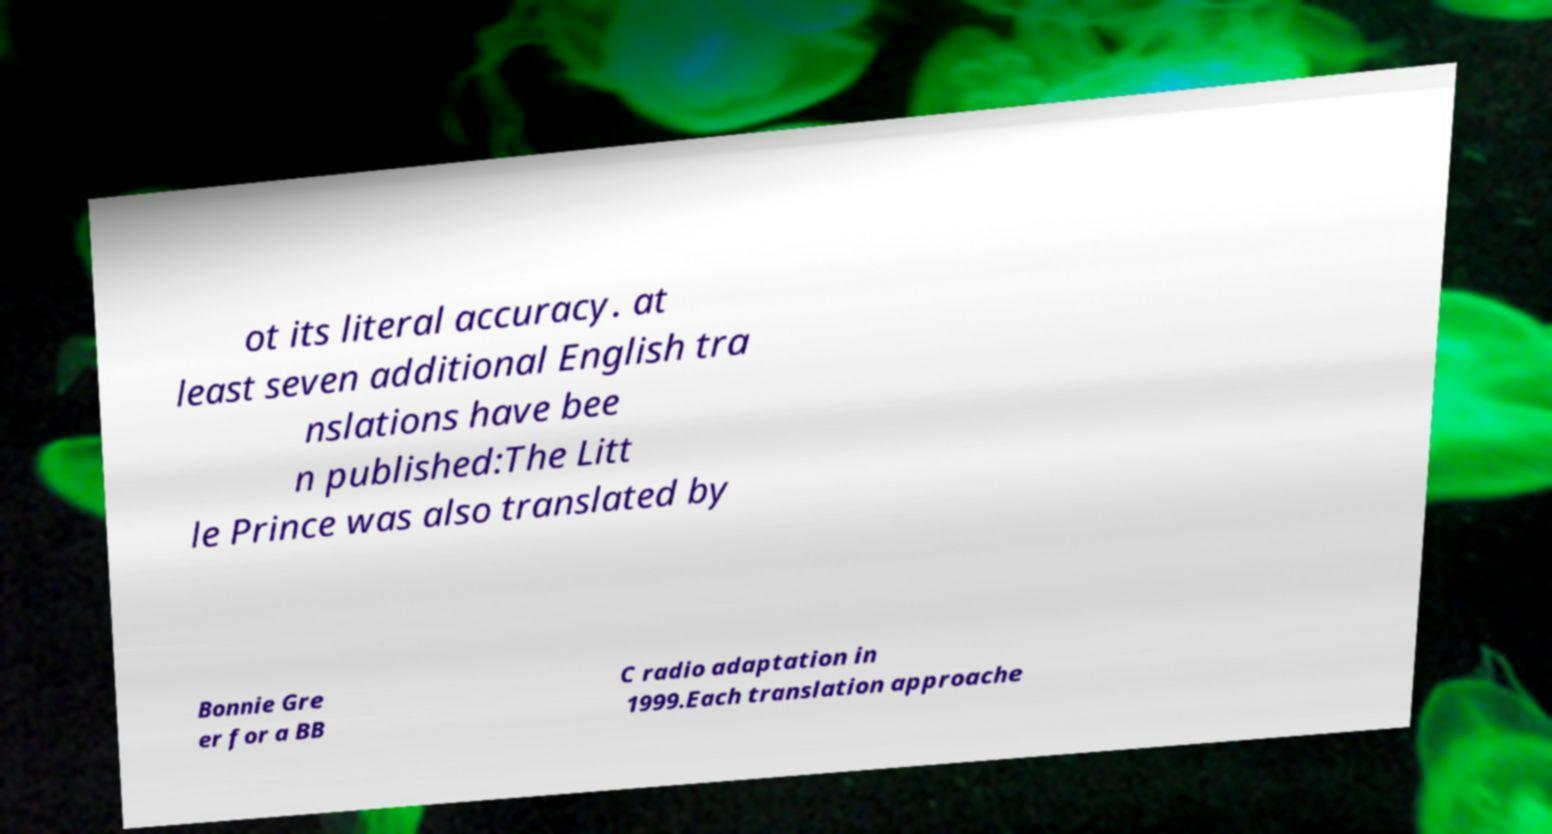What messages or text are displayed in this image? I need them in a readable, typed format. ot its literal accuracy. at least seven additional English tra nslations have bee n published:The Litt le Prince was also translated by Bonnie Gre er for a BB C radio adaptation in 1999.Each translation approache 